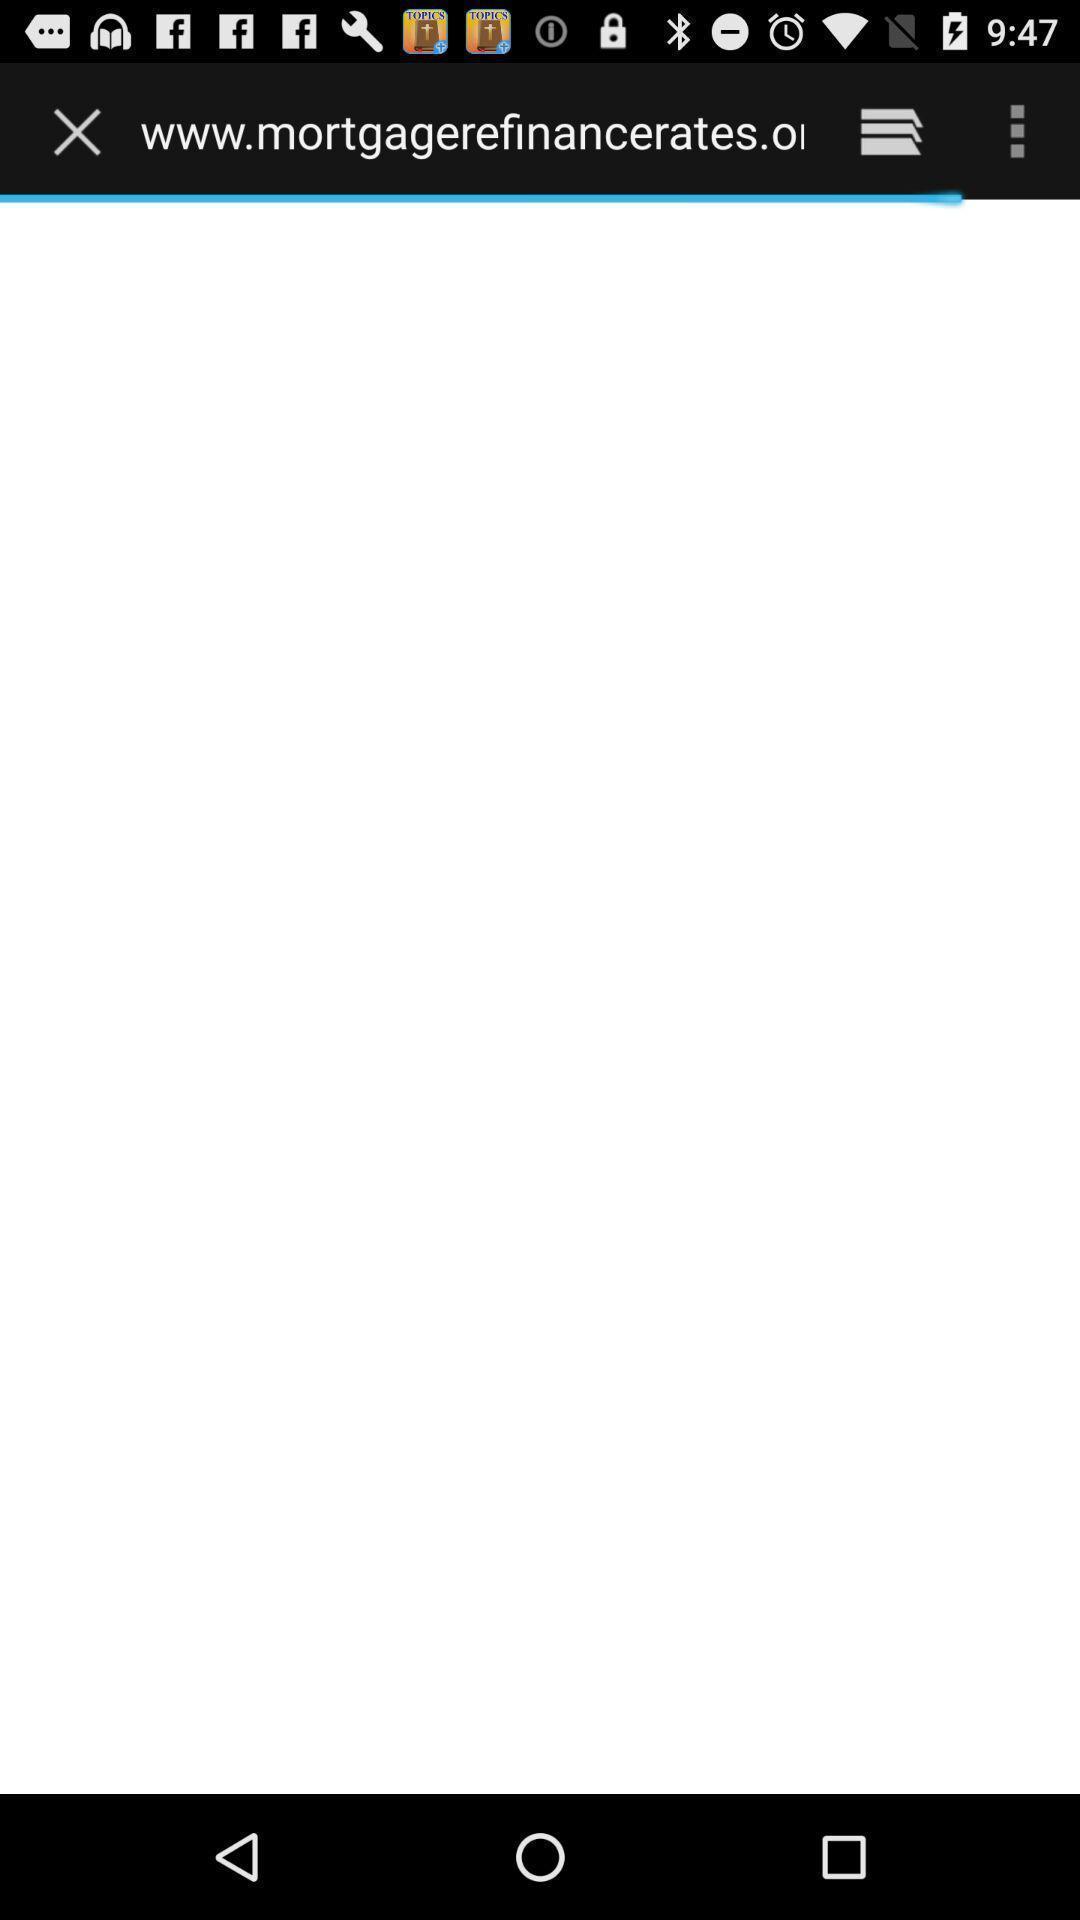Explain what's happening in this screen capture. Progress bar loading a webpage. 